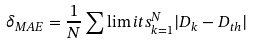Convert formula to latex. <formula><loc_0><loc_0><loc_500><loc_500>\delta _ { M A E } = \frac { 1 } { N } \sum \lim i t s ^ { N } _ { k = 1 } | D _ { k } - D _ { t h } |</formula> 